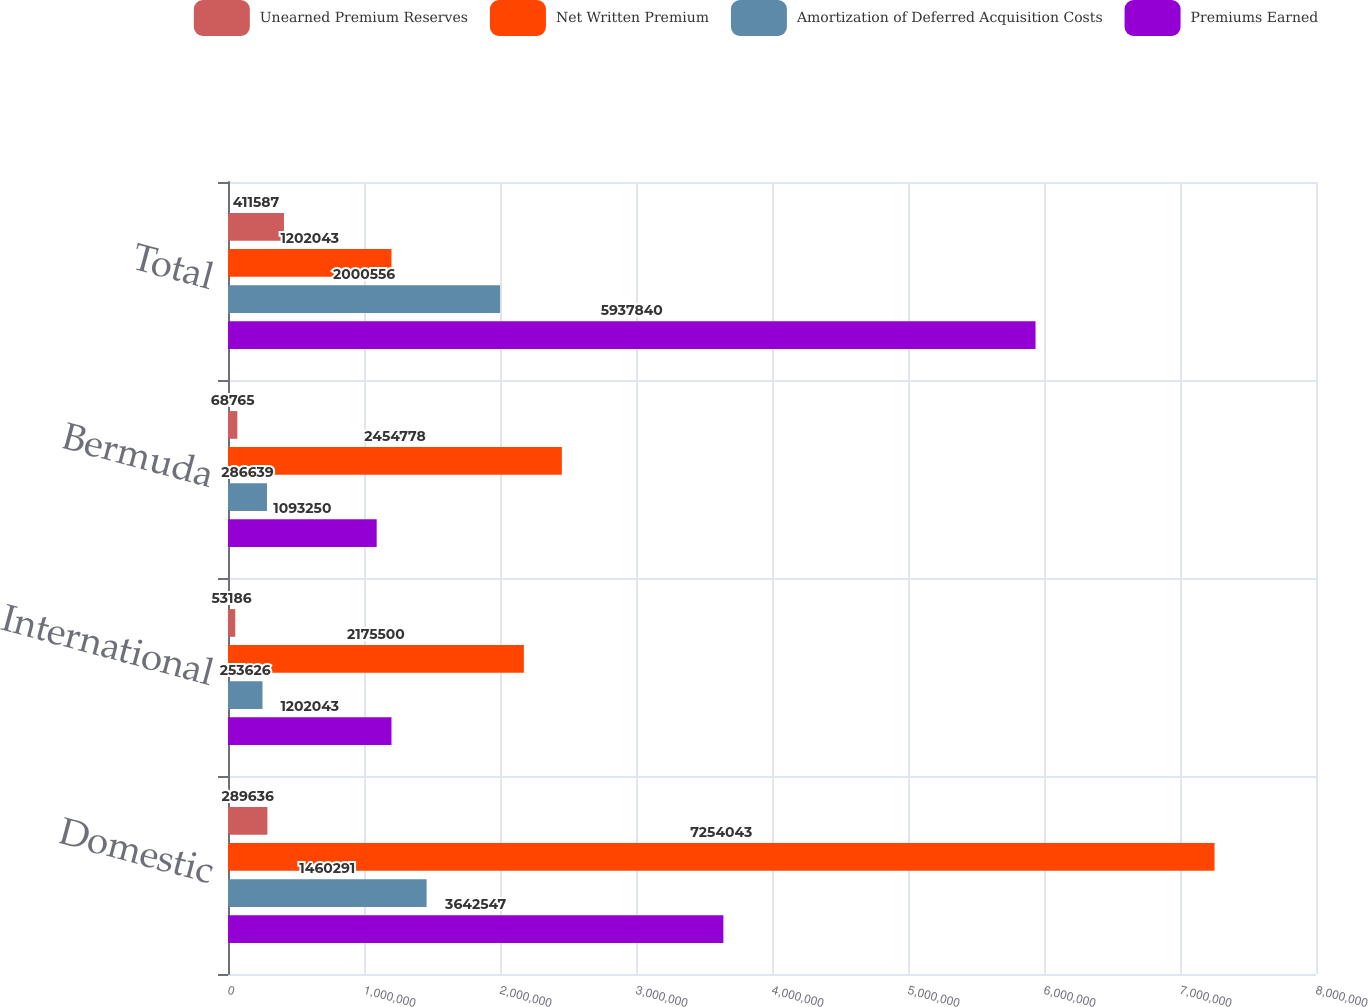<chart> <loc_0><loc_0><loc_500><loc_500><stacked_bar_chart><ecel><fcel>Domestic<fcel>International<fcel>Bermuda<fcel>Total<nl><fcel>Unearned Premium Reserves<fcel>289636<fcel>53186<fcel>68765<fcel>411587<nl><fcel>Net Written Premium<fcel>7.25404e+06<fcel>2.1755e+06<fcel>2.45478e+06<fcel>1.20204e+06<nl><fcel>Amortization of Deferred Acquisition Costs<fcel>1.46029e+06<fcel>253626<fcel>286639<fcel>2.00056e+06<nl><fcel>Premiums Earned<fcel>3.64255e+06<fcel>1.20204e+06<fcel>1.09325e+06<fcel>5.93784e+06<nl></chart> 